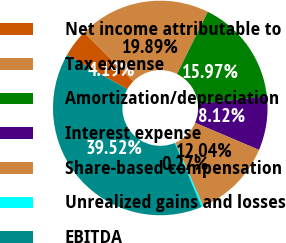Convert chart. <chart><loc_0><loc_0><loc_500><loc_500><pie_chart><fcel>Net income attributable to<fcel>Tax expense<fcel>Amortization/depreciation<fcel>Interest expense<fcel>Share-based compensation<fcel>Unrealized gains and losses<fcel>EBITDA<nl><fcel>4.19%<fcel>19.89%<fcel>15.97%<fcel>8.12%<fcel>12.04%<fcel>0.27%<fcel>39.52%<nl></chart> 